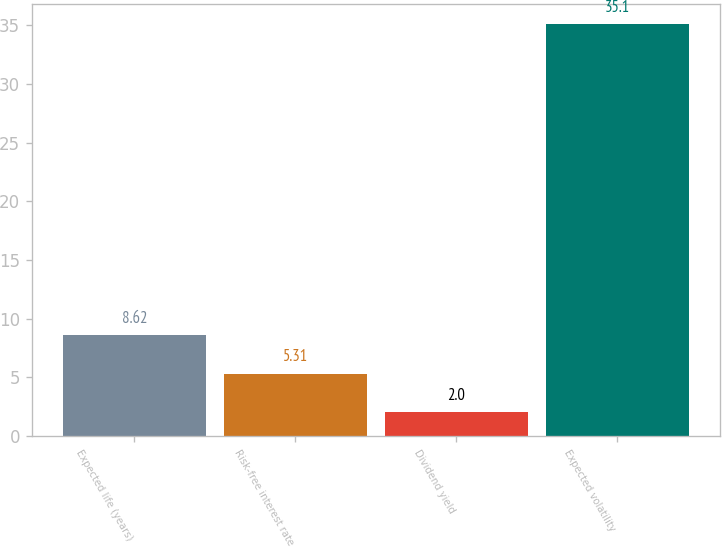Convert chart to OTSL. <chart><loc_0><loc_0><loc_500><loc_500><bar_chart><fcel>Expected life (years)<fcel>Risk-free interest rate<fcel>Dividend yield<fcel>Expected volatility<nl><fcel>8.62<fcel>5.31<fcel>2<fcel>35.1<nl></chart> 